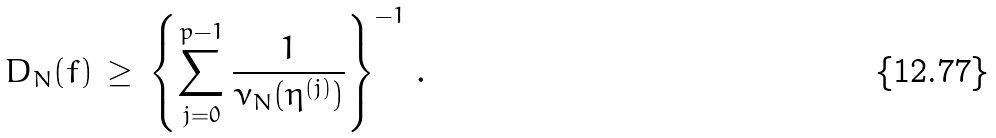<formula> <loc_0><loc_0><loc_500><loc_500>D _ { N } ( f ) \, \geq \, \left \{ \sum _ { j = 0 } ^ { p - 1 } \frac { 1 } { \nu _ { N } ( \eta ^ { ( j ) } ) } \right \} ^ { - 1 } \, .</formula> 